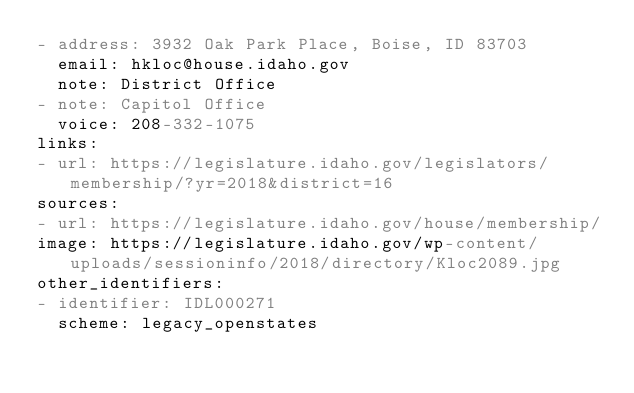Convert code to text. <code><loc_0><loc_0><loc_500><loc_500><_YAML_>- address: 3932 Oak Park Place, Boise, ID 83703
  email: hkloc@house.idaho.gov
  note: District Office
- note: Capitol Office
  voice: 208-332-1075
links:
- url: https://legislature.idaho.gov/legislators/membership/?yr=2018&district=16
sources:
- url: https://legislature.idaho.gov/house/membership/
image: https://legislature.idaho.gov/wp-content/uploads/sessioninfo/2018/directory/Kloc2089.jpg
other_identifiers:
- identifier: IDL000271
  scheme: legacy_openstates
</code> 